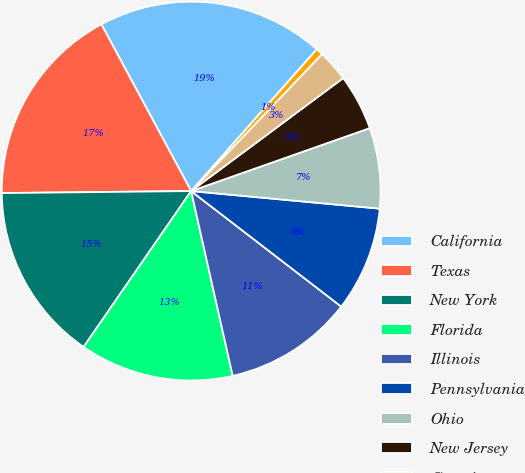Convert chart to OTSL. <chart><loc_0><loc_0><loc_500><loc_500><pie_chart><fcel>California<fcel>Texas<fcel>New York<fcel>Florida<fcel>Illinois<fcel>Pennsylvania<fcel>Ohio<fcel>New Jersey<fcel>Georgia<fcel>Michigan<nl><fcel>19.4%<fcel>17.31%<fcel>15.22%<fcel>13.13%<fcel>11.04%<fcel>8.96%<fcel>6.87%<fcel>4.78%<fcel>2.69%<fcel>0.6%<nl></chart> 